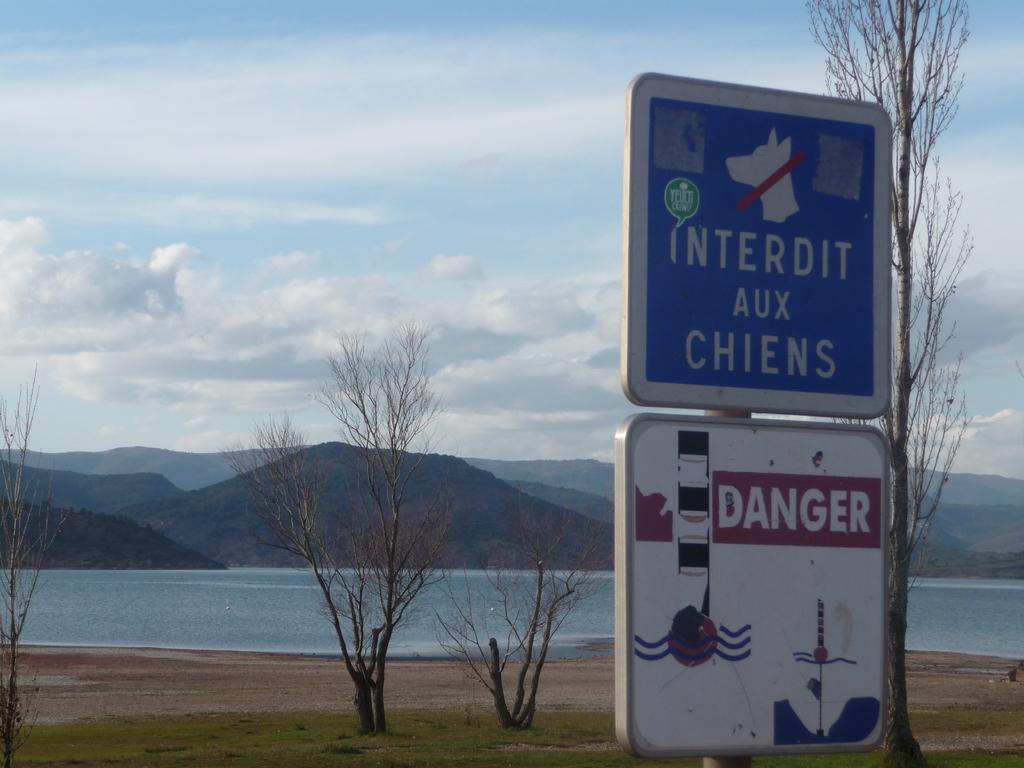Can you describe this image briefly? In this picture, we can see some sign boards, ground, grass and we can see some dry trees, water, mountains and the sky with clouds. 